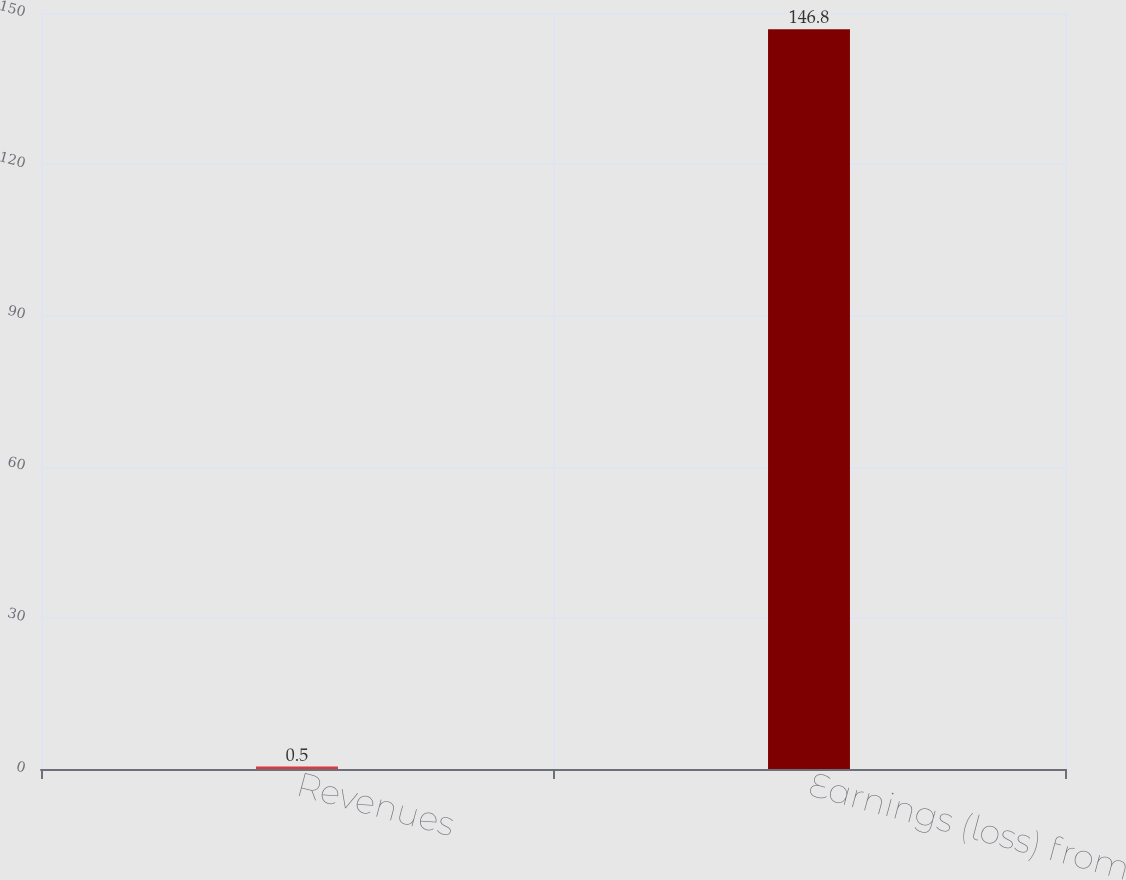Convert chart. <chart><loc_0><loc_0><loc_500><loc_500><bar_chart><fcel>Revenues<fcel>Earnings (loss) from<nl><fcel>0.5<fcel>146.8<nl></chart> 